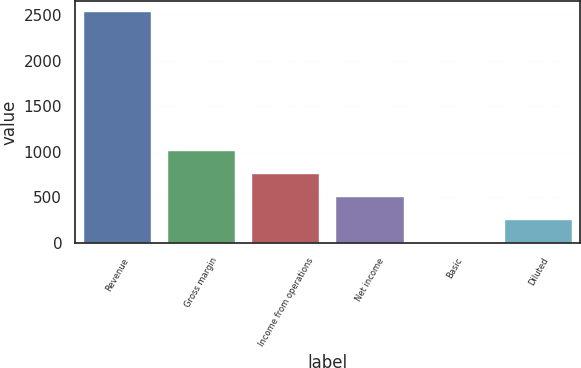<chart> <loc_0><loc_0><loc_500><loc_500><bar_chart><fcel>Revenue<fcel>Gross margin<fcel>Income from operations<fcel>Net income<fcel>Basic<fcel>Diluted<nl><fcel>2529<fcel>1011.61<fcel>758.71<fcel>505.81<fcel>0.01<fcel>252.91<nl></chart> 